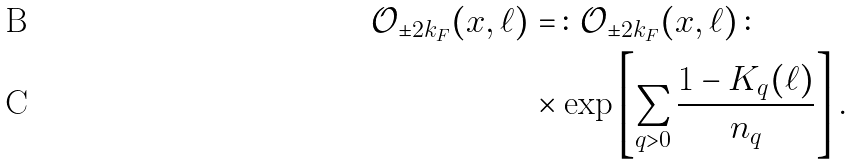Convert formula to latex. <formula><loc_0><loc_0><loc_500><loc_500>\mathcal { O } _ { \pm 2 k _ { F } } ( x , \ell ) & = \, \colon \, \mathcal { O } _ { \pm 2 k _ { F } } ( x , \ell ) \, \colon \\ & \times \exp \left [ \sum _ { q > 0 } \frac { 1 - K _ { q } ( \ell ) } { n _ { q } } \right ] .</formula> 